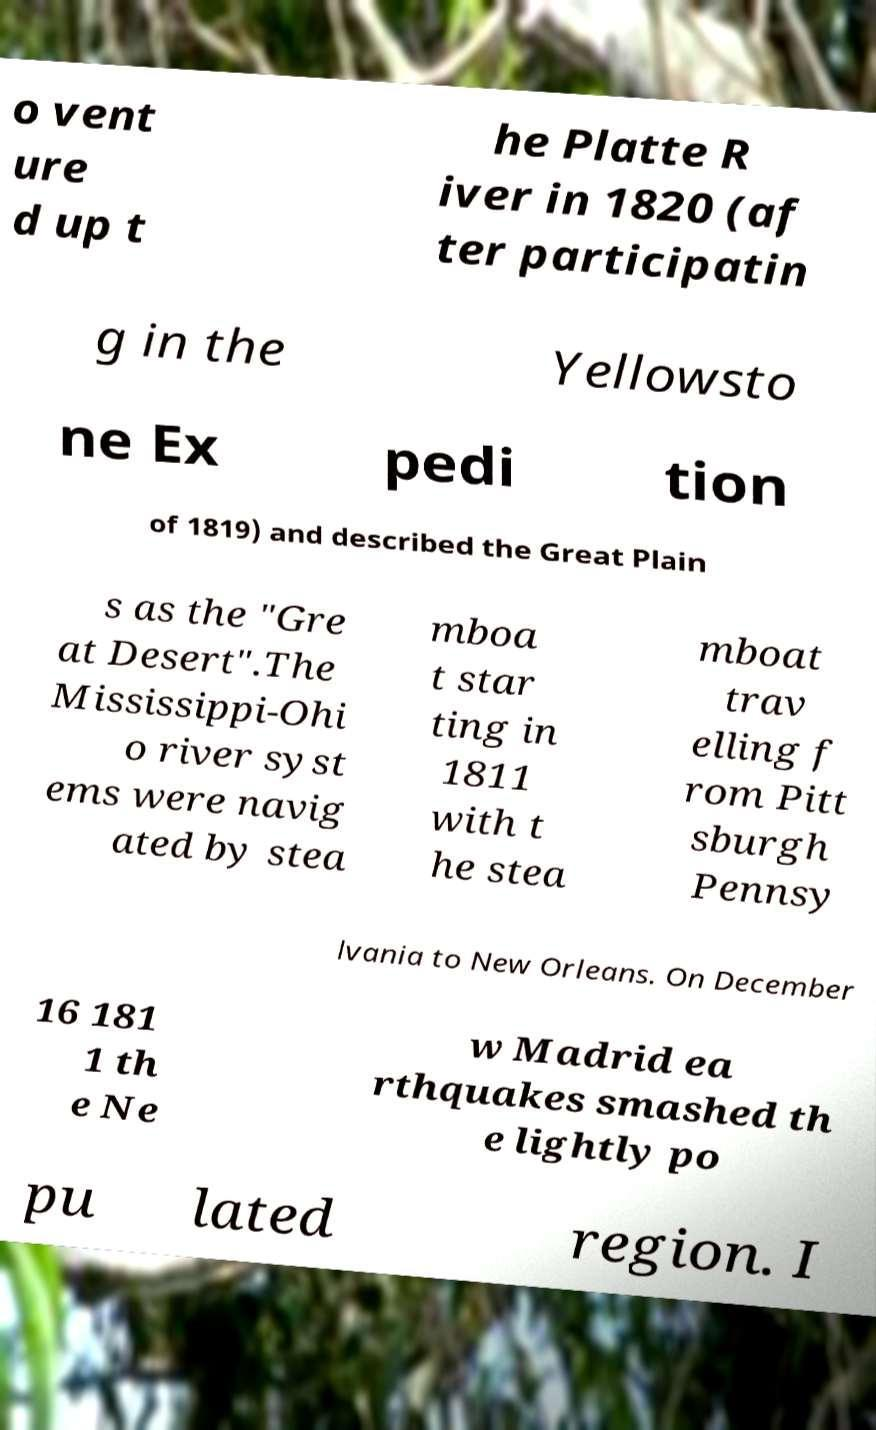Could you assist in decoding the text presented in this image and type it out clearly? o vent ure d up t he Platte R iver in 1820 (af ter participatin g in the Yellowsto ne Ex pedi tion of 1819) and described the Great Plain s as the "Gre at Desert".The Mississippi-Ohi o river syst ems were navig ated by stea mboa t star ting in 1811 with t he stea mboat trav elling f rom Pitt sburgh Pennsy lvania to New Orleans. On December 16 181 1 th e Ne w Madrid ea rthquakes smashed th e lightly po pu lated region. I 